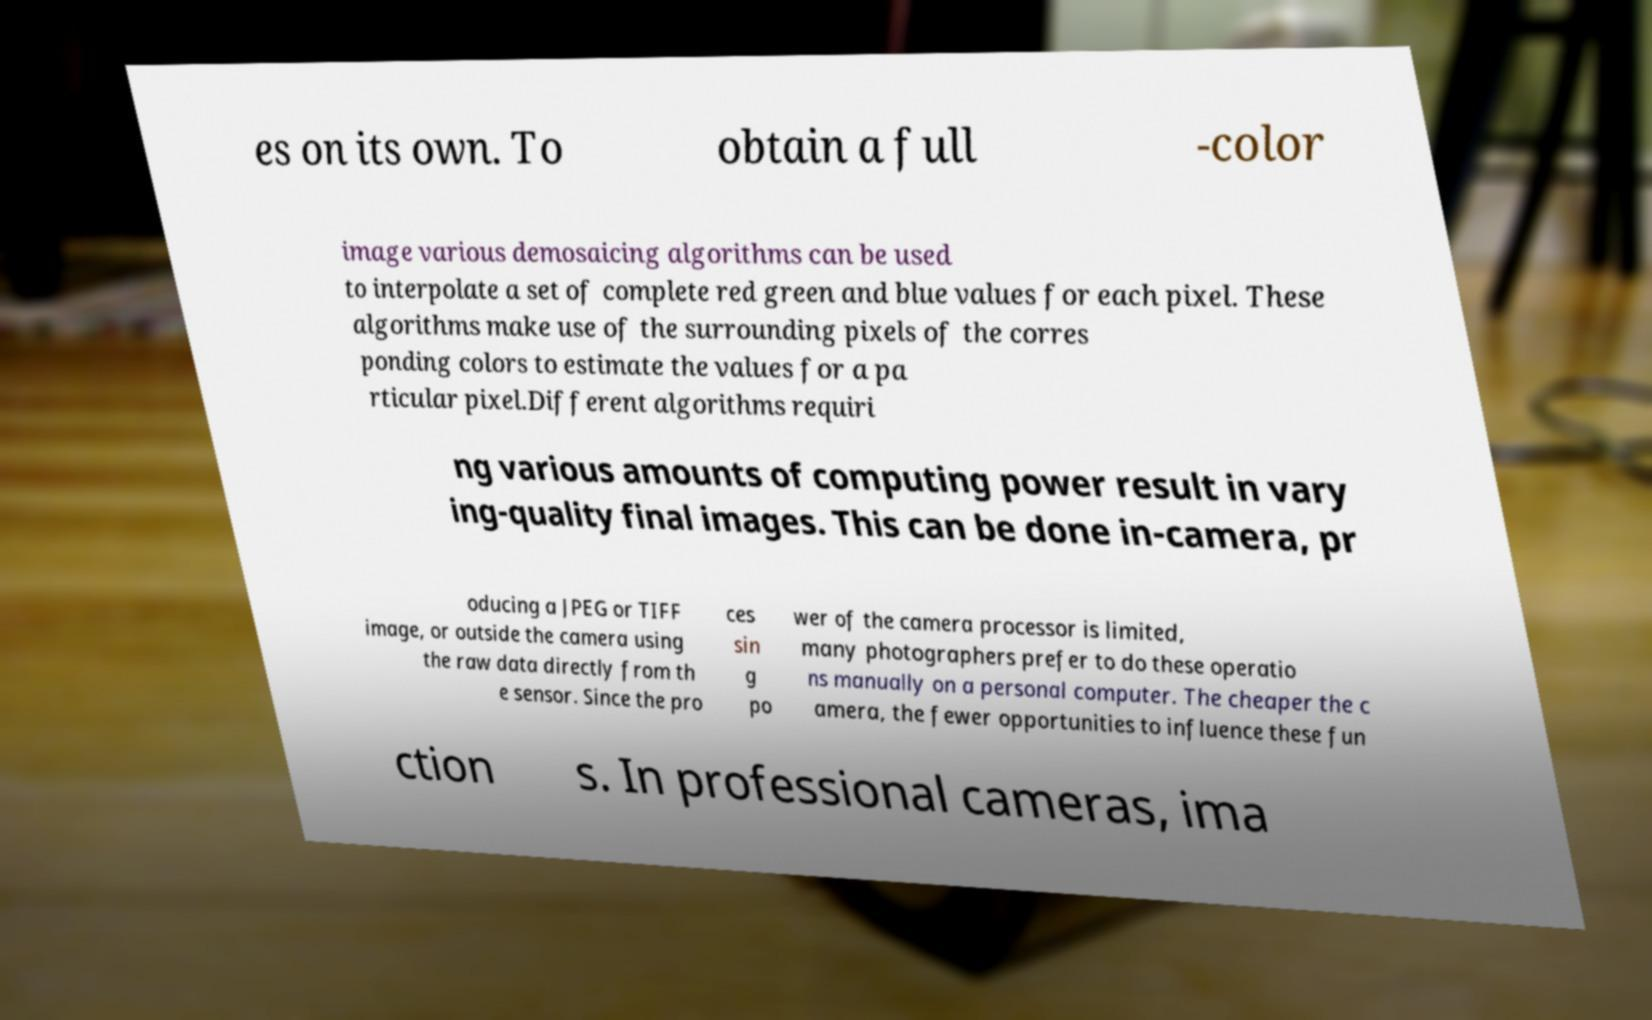There's text embedded in this image that I need extracted. Can you transcribe it verbatim? es on its own. To obtain a full -color image various demosaicing algorithms can be used to interpolate a set of complete red green and blue values for each pixel. These algorithms make use of the surrounding pixels of the corres ponding colors to estimate the values for a pa rticular pixel.Different algorithms requiri ng various amounts of computing power result in vary ing-quality final images. This can be done in-camera, pr oducing a JPEG or TIFF image, or outside the camera using the raw data directly from th e sensor. Since the pro ces sin g po wer of the camera processor is limited, many photographers prefer to do these operatio ns manually on a personal computer. The cheaper the c amera, the fewer opportunities to influence these fun ction s. In professional cameras, ima 